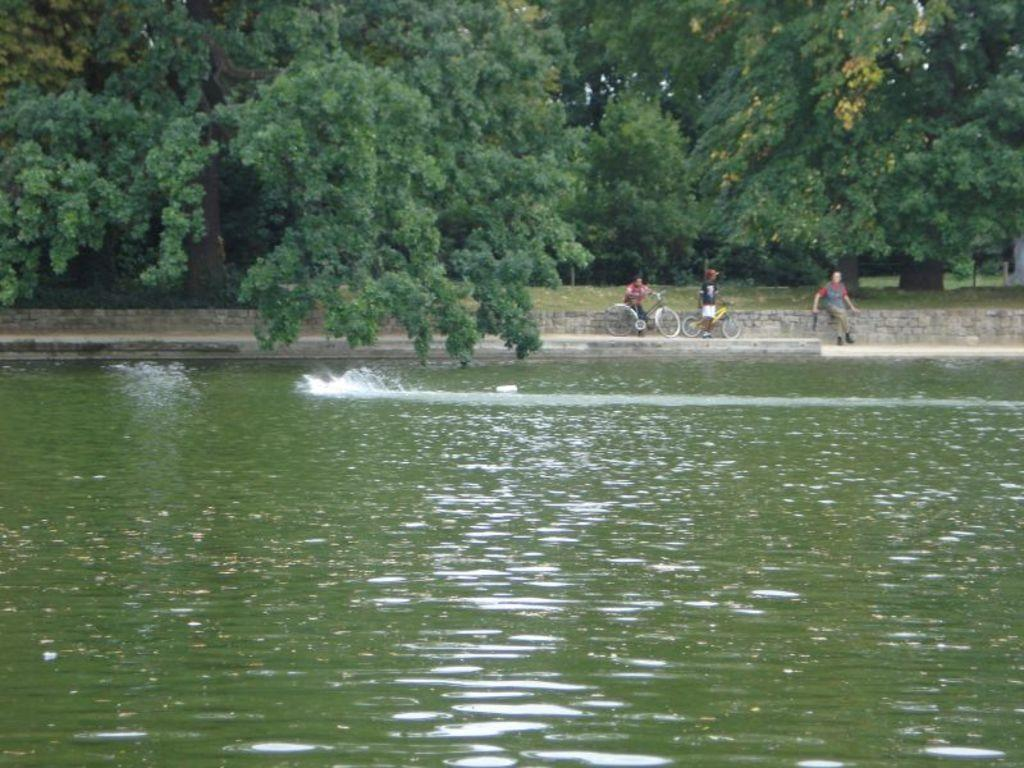What is the main element present in the image? There is water in the image. What type of vegetation can be seen in the image? There are trees and grass in the image. How many people are present in the image? There are three people standing in the image. What objects are associated with the people in the image? There are bicycles in the image. What type of cabbage is being harvested by the farmer in the image? There is no farmer or cabbage present in the image. What time of day is it in the image, considering the presence of the morning? The time of day cannot be determined from the image, as there is no reference to morning or any other time of day. 